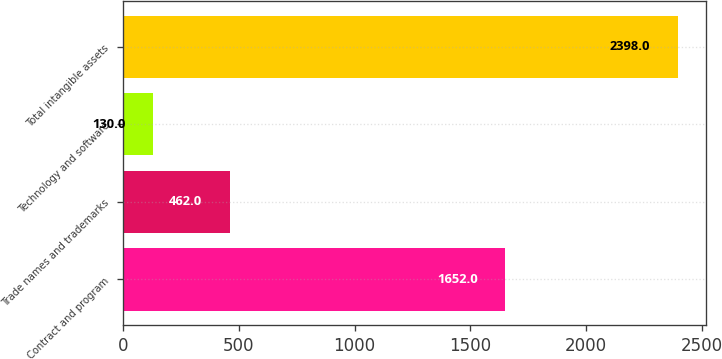Convert chart to OTSL. <chart><loc_0><loc_0><loc_500><loc_500><bar_chart><fcel>Contract and program<fcel>Trade names and trademarks<fcel>Technology and software<fcel>Total intangible assets<nl><fcel>1652<fcel>462<fcel>130<fcel>2398<nl></chart> 